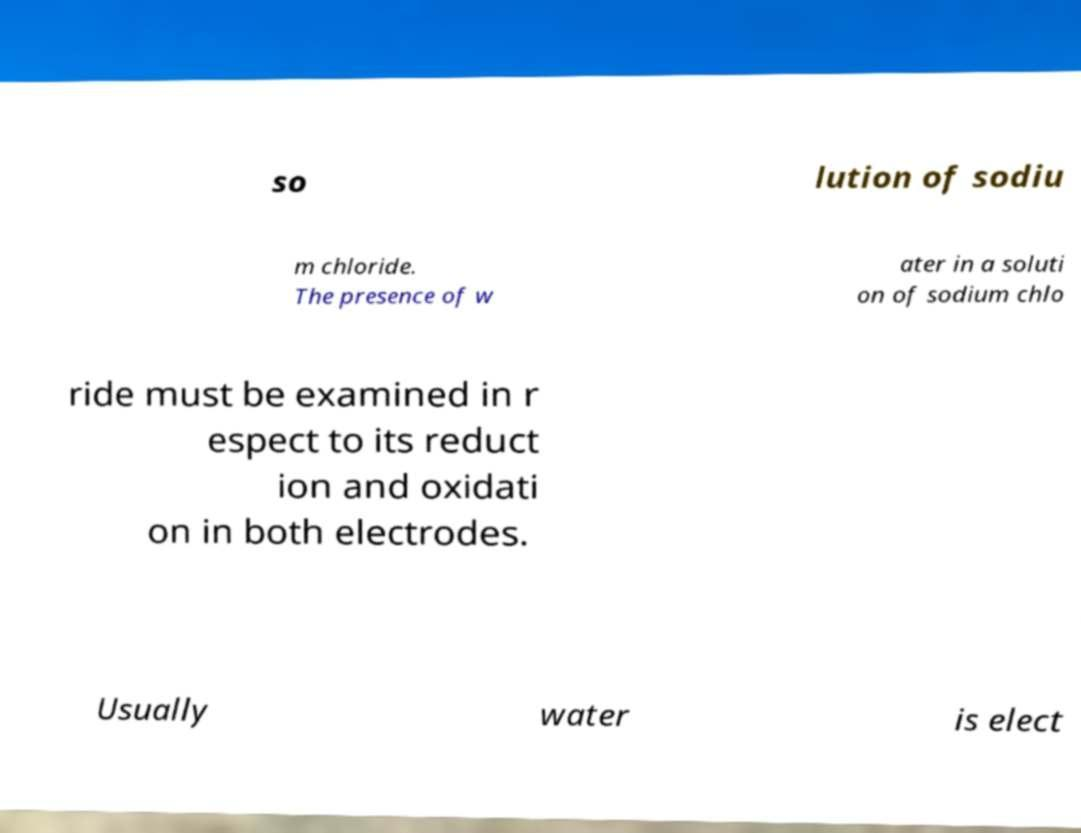For documentation purposes, I need the text within this image transcribed. Could you provide that? so lution of sodiu m chloride. The presence of w ater in a soluti on of sodium chlo ride must be examined in r espect to its reduct ion and oxidati on in both electrodes. Usually water is elect 